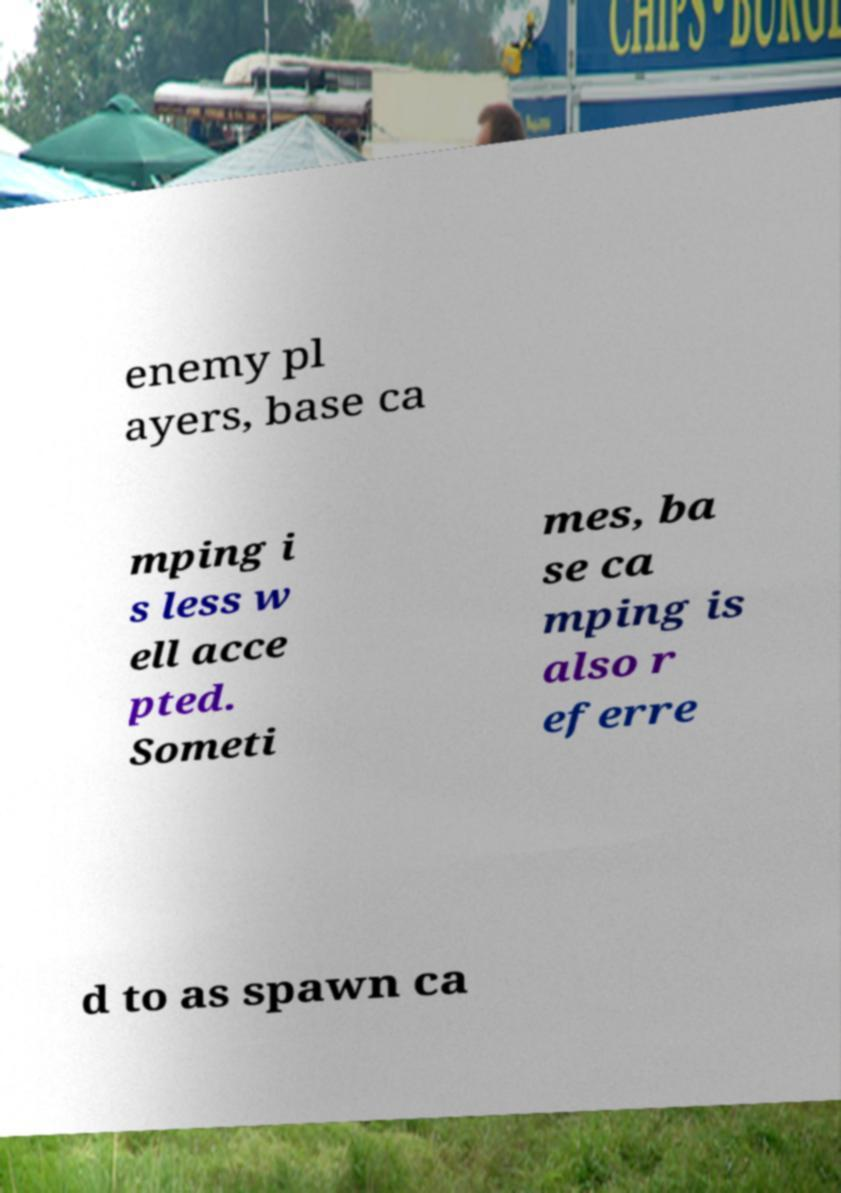There's text embedded in this image that I need extracted. Can you transcribe it verbatim? enemy pl ayers, base ca mping i s less w ell acce pted. Someti mes, ba se ca mping is also r eferre d to as spawn ca 